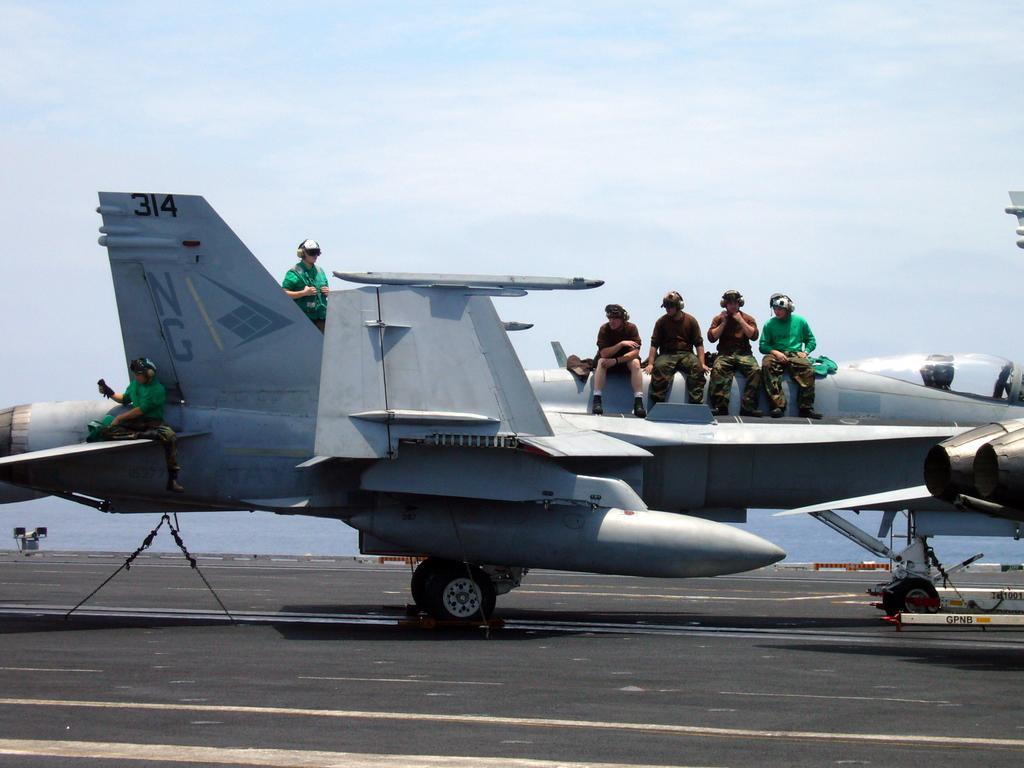What is the unusual object on the road in the image? There is an aircraft on the road in the image. What are the people on the aircraft doing? The people are sitting on the plane. Can you describe the person standing near the aircraft? There is a person standing near the aircraft. What can be seen in the background of the image? The sky is clear in the background. What type of chess game is being played on the aircraft in the image? There is no chess game visible in the image; it features an aircraft on the road with people sitting on it and a person standing nearby. How many children are visible in the image? There is no mention of children in the image; it features an aircraft on the road with people sitting on it and a person standing nearby. 